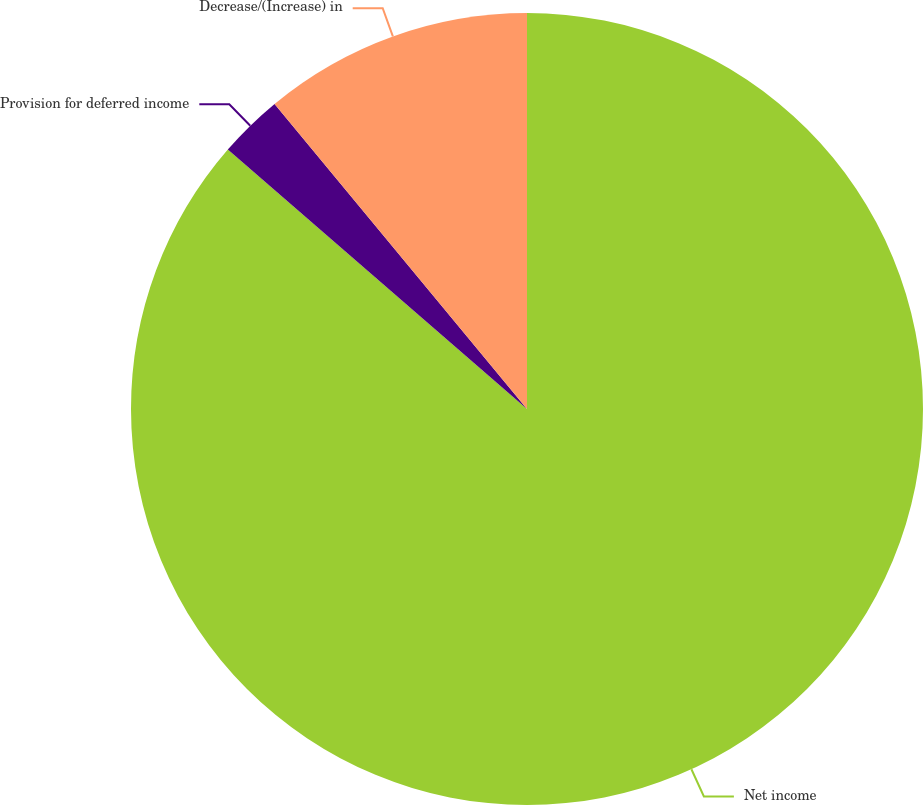<chart> <loc_0><loc_0><loc_500><loc_500><pie_chart><fcel>Net income<fcel>Provision for deferred income<fcel>Decrease/(Increase) in<nl><fcel>86.37%<fcel>2.63%<fcel>11.0%<nl></chart> 